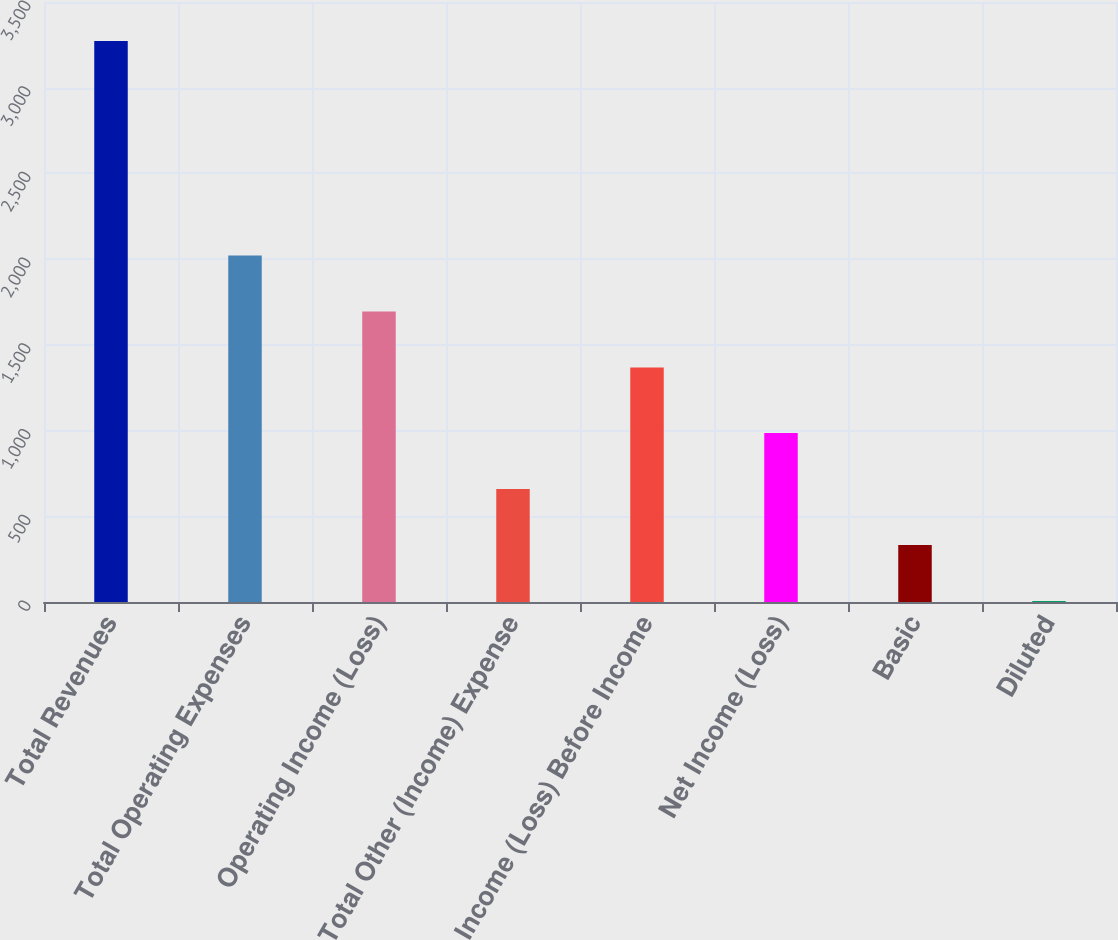<chart> <loc_0><loc_0><loc_500><loc_500><bar_chart><fcel>Total Revenues<fcel>Total Operating Expenses<fcel>Operating Income (Loss)<fcel>Total Other (Income) Expense<fcel>Income (Loss) Before Income<fcel>Net Income (Loss)<fcel>Basic<fcel>Diluted<nl><fcel>3272<fcel>2021.31<fcel>1694.65<fcel>658.77<fcel>1368<fcel>985.42<fcel>332.11<fcel>5.45<nl></chart> 